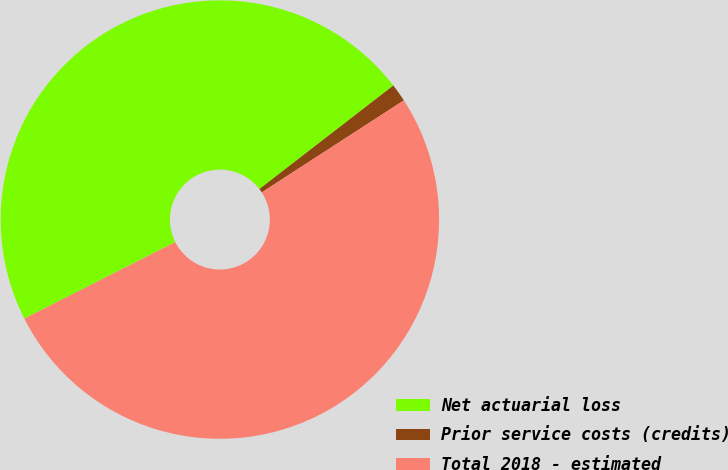<chart> <loc_0><loc_0><loc_500><loc_500><pie_chart><fcel>Net actuarial loss<fcel>Prior service costs (credits)<fcel>Total 2018 - estimated<nl><fcel>46.99%<fcel>1.32%<fcel>51.69%<nl></chart> 